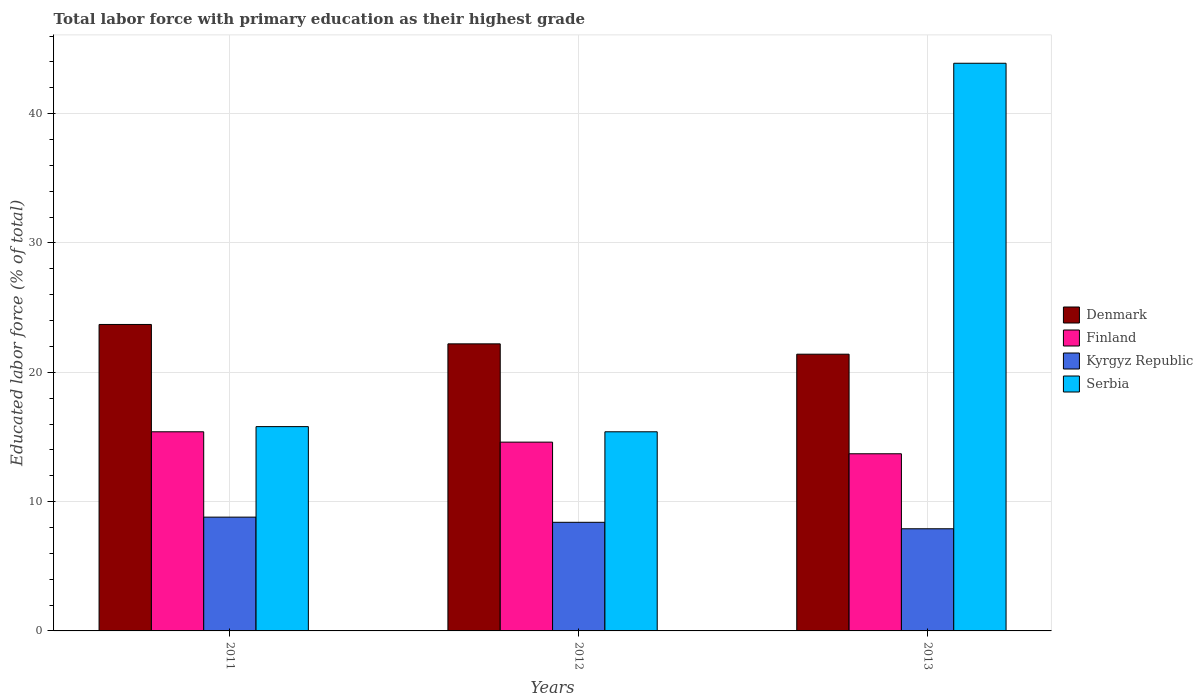How many different coloured bars are there?
Your answer should be very brief. 4. How many groups of bars are there?
Keep it short and to the point. 3. Are the number of bars per tick equal to the number of legend labels?
Ensure brevity in your answer.  Yes. How many bars are there on the 1st tick from the left?
Ensure brevity in your answer.  4. How many bars are there on the 1st tick from the right?
Give a very brief answer. 4. What is the label of the 2nd group of bars from the left?
Ensure brevity in your answer.  2012. In how many cases, is the number of bars for a given year not equal to the number of legend labels?
Provide a succinct answer. 0. What is the percentage of total labor force with primary education in Denmark in 2011?
Ensure brevity in your answer.  23.7. Across all years, what is the maximum percentage of total labor force with primary education in Kyrgyz Republic?
Make the answer very short. 8.8. Across all years, what is the minimum percentage of total labor force with primary education in Serbia?
Your answer should be compact. 15.4. In which year was the percentage of total labor force with primary education in Finland maximum?
Offer a terse response. 2011. What is the total percentage of total labor force with primary education in Denmark in the graph?
Offer a very short reply. 67.3. What is the difference between the percentage of total labor force with primary education in Finland in 2011 and that in 2012?
Your response must be concise. 0.8. What is the difference between the percentage of total labor force with primary education in Kyrgyz Republic in 2011 and the percentage of total labor force with primary education in Serbia in 2013?
Give a very brief answer. -35.1. What is the average percentage of total labor force with primary education in Serbia per year?
Ensure brevity in your answer.  25.03. In the year 2013, what is the difference between the percentage of total labor force with primary education in Denmark and percentage of total labor force with primary education in Finland?
Your response must be concise. 7.7. In how many years, is the percentage of total labor force with primary education in Denmark greater than 2 %?
Offer a very short reply. 3. What is the ratio of the percentage of total labor force with primary education in Finland in 2012 to that in 2013?
Provide a succinct answer. 1.07. Is the percentage of total labor force with primary education in Finland in 2012 less than that in 2013?
Make the answer very short. No. Is the difference between the percentage of total labor force with primary education in Denmark in 2012 and 2013 greater than the difference between the percentage of total labor force with primary education in Finland in 2012 and 2013?
Provide a succinct answer. No. What is the difference between the highest and the second highest percentage of total labor force with primary education in Finland?
Make the answer very short. 0.8. What is the difference between the highest and the lowest percentage of total labor force with primary education in Kyrgyz Republic?
Your response must be concise. 0.9. In how many years, is the percentage of total labor force with primary education in Finland greater than the average percentage of total labor force with primary education in Finland taken over all years?
Your answer should be very brief. 2. Is the sum of the percentage of total labor force with primary education in Kyrgyz Republic in 2011 and 2012 greater than the maximum percentage of total labor force with primary education in Serbia across all years?
Make the answer very short. No. Is it the case that in every year, the sum of the percentage of total labor force with primary education in Finland and percentage of total labor force with primary education in Serbia is greater than the sum of percentage of total labor force with primary education in Denmark and percentage of total labor force with primary education in Kyrgyz Republic?
Your response must be concise. Yes. What does the 3rd bar from the left in 2013 represents?
Offer a terse response. Kyrgyz Republic. What does the 3rd bar from the right in 2011 represents?
Your answer should be compact. Finland. Is it the case that in every year, the sum of the percentage of total labor force with primary education in Denmark and percentage of total labor force with primary education in Serbia is greater than the percentage of total labor force with primary education in Kyrgyz Republic?
Provide a succinct answer. Yes. Are all the bars in the graph horizontal?
Offer a very short reply. No. What is the difference between two consecutive major ticks on the Y-axis?
Give a very brief answer. 10. Are the values on the major ticks of Y-axis written in scientific E-notation?
Ensure brevity in your answer.  No. Does the graph contain any zero values?
Give a very brief answer. No. Where does the legend appear in the graph?
Your answer should be compact. Center right. What is the title of the graph?
Provide a succinct answer. Total labor force with primary education as their highest grade. Does "Paraguay" appear as one of the legend labels in the graph?
Ensure brevity in your answer.  No. What is the label or title of the X-axis?
Keep it short and to the point. Years. What is the label or title of the Y-axis?
Provide a succinct answer. Educated labor force (% of total). What is the Educated labor force (% of total) of Denmark in 2011?
Your answer should be compact. 23.7. What is the Educated labor force (% of total) of Finland in 2011?
Ensure brevity in your answer.  15.4. What is the Educated labor force (% of total) in Kyrgyz Republic in 2011?
Your response must be concise. 8.8. What is the Educated labor force (% of total) of Serbia in 2011?
Offer a very short reply. 15.8. What is the Educated labor force (% of total) in Denmark in 2012?
Your response must be concise. 22.2. What is the Educated labor force (% of total) in Finland in 2012?
Provide a succinct answer. 14.6. What is the Educated labor force (% of total) of Kyrgyz Republic in 2012?
Provide a short and direct response. 8.4. What is the Educated labor force (% of total) of Serbia in 2012?
Offer a very short reply. 15.4. What is the Educated labor force (% of total) of Denmark in 2013?
Make the answer very short. 21.4. What is the Educated labor force (% of total) of Finland in 2013?
Your answer should be compact. 13.7. What is the Educated labor force (% of total) in Kyrgyz Republic in 2013?
Provide a short and direct response. 7.9. What is the Educated labor force (% of total) in Serbia in 2013?
Keep it short and to the point. 43.9. Across all years, what is the maximum Educated labor force (% of total) in Denmark?
Make the answer very short. 23.7. Across all years, what is the maximum Educated labor force (% of total) in Finland?
Ensure brevity in your answer.  15.4. Across all years, what is the maximum Educated labor force (% of total) in Kyrgyz Republic?
Provide a succinct answer. 8.8. Across all years, what is the maximum Educated labor force (% of total) of Serbia?
Your answer should be very brief. 43.9. Across all years, what is the minimum Educated labor force (% of total) of Denmark?
Your response must be concise. 21.4. Across all years, what is the minimum Educated labor force (% of total) in Finland?
Offer a terse response. 13.7. Across all years, what is the minimum Educated labor force (% of total) of Kyrgyz Republic?
Give a very brief answer. 7.9. Across all years, what is the minimum Educated labor force (% of total) in Serbia?
Provide a short and direct response. 15.4. What is the total Educated labor force (% of total) in Denmark in the graph?
Provide a succinct answer. 67.3. What is the total Educated labor force (% of total) in Finland in the graph?
Provide a succinct answer. 43.7. What is the total Educated labor force (% of total) in Kyrgyz Republic in the graph?
Ensure brevity in your answer.  25.1. What is the total Educated labor force (% of total) of Serbia in the graph?
Your response must be concise. 75.1. What is the difference between the Educated labor force (% of total) of Finland in 2011 and that in 2012?
Your answer should be compact. 0.8. What is the difference between the Educated labor force (% of total) of Serbia in 2011 and that in 2012?
Make the answer very short. 0.4. What is the difference between the Educated labor force (% of total) of Kyrgyz Republic in 2011 and that in 2013?
Provide a succinct answer. 0.9. What is the difference between the Educated labor force (% of total) of Serbia in 2011 and that in 2013?
Your response must be concise. -28.1. What is the difference between the Educated labor force (% of total) of Finland in 2012 and that in 2013?
Provide a succinct answer. 0.9. What is the difference between the Educated labor force (% of total) of Kyrgyz Republic in 2012 and that in 2013?
Offer a terse response. 0.5. What is the difference between the Educated labor force (% of total) of Serbia in 2012 and that in 2013?
Give a very brief answer. -28.5. What is the difference between the Educated labor force (% of total) of Finland in 2011 and the Educated labor force (% of total) of Serbia in 2012?
Keep it short and to the point. 0. What is the difference between the Educated labor force (% of total) of Kyrgyz Republic in 2011 and the Educated labor force (% of total) of Serbia in 2012?
Your answer should be very brief. -6.6. What is the difference between the Educated labor force (% of total) in Denmark in 2011 and the Educated labor force (% of total) in Finland in 2013?
Make the answer very short. 10. What is the difference between the Educated labor force (% of total) of Denmark in 2011 and the Educated labor force (% of total) of Serbia in 2013?
Your answer should be very brief. -20.2. What is the difference between the Educated labor force (% of total) of Finland in 2011 and the Educated labor force (% of total) of Kyrgyz Republic in 2013?
Your response must be concise. 7.5. What is the difference between the Educated labor force (% of total) of Finland in 2011 and the Educated labor force (% of total) of Serbia in 2013?
Offer a terse response. -28.5. What is the difference between the Educated labor force (% of total) of Kyrgyz Republic in 2011 and the Educated labor force (% of total) of Serbia in 2013?
Make the answer very short. -35.1. What is the difference between the Educated labor force (% of total) of Denmark in 2012 and the Educated labor force (% of total) of Finland in 2013?
Offer a very short reply. 8.5. What is the difference between the Educated labor force (% of total) in Denmark in 2012 and the Educated labor force (% of total) in Serbia in 2013?
Make the answer very short. -21.7. What is the difference between the Educated labor force (% of total) in Finland in 2012 and the Educated labor force (% of total) in Kyrgyz Republic in 2013?
Offer a terse response. 6.7. What is the difference between the Educated labor force (% of total) of Finland in 2012 and the Educated labor force (% of total) of Serbia in 2013?
Your answer should be very brief. -29.3. What is the difference between the Educated labor force (% of total) of Kyrgyz Republic in 2012 and the Educated labor force (% of total) of Serbia in 2013?
Offer a very short reply. -35.5. What is the average Educated labor force (% of total) in Denmark per year?
Provide a short and direct response. 22.43. What is the average Educated labor force (% of total) in Finland per year?
Keep it short and to the point. 14.57. What is the average Educated labor force (% of total) in Kyrgyz Republic per year?
Offer a very short reply. 8.37. What is the average Educated labor force (% of total) in Serbia per year?
Your response must be concise. 25.03. In the year 2011, what is the difference between the Educated labor force (% of total) of Denmark and Educated labor force (% of total) of Finland?
Your response must be concise. 8.3. In the year 2011, what is the difference between the Educated labor force (% of total) of Denmark and Educated labor force (% of total) of Kyrgyz Republic?
Offer a terse response. 14.9. In the year 2011, what is the difference between the Educated labor force (% of total) in Finland and Educated labor force (% of total) in Kyrgyz Republic?
Offer a very short reply. 6.6. In the year 2011, what is the difference between the Educated labor force (% of total) of Finland and Educated labor force (% of total) of Serbia?
Your answer should be very brief. -0.4. In the year 2012, what is the difference between the Educated labor force (% of total) of Denmark and Educated labor force (% of total) of Finland?
Provide a succinct answer. 7.6. In the year 2012, what is the difference between the Educated labor force (% of total) in Denmark and Educated labor force (% of total) in Kyrgyz Republic?
Your answer should be compact. 13.8. In the year 2012, what is the difference between the Educated labor force (% of total) of Denmark and Educated labor force (% of total) of Serbia?
Your answer should be very brief. 6.8. In the year 2012, what is the difference between the Educated labor force (% of total) of Finland and Educated labor force (% of total) of Kyrgyz Republic?
Your answer should be compact. 6.2. In the year 2012, what is the difference between the Educated labor force (% of total) in Finland and Educated labor force (% of total) in Serbia?
Provide a succinct answer. -0.8. In the year 2012, what is the difference between the Educated labor force (% of total) of Kyrgyz Republic and Educated labor force (% of total) of Serbia?
Offer a very short reply. -7. In the year 2013, what is the difference between the Educated labor force (% of total) in Denmark and Educated labor force (% of total) in Kyrgyz Republic?
Your answer should be compact. 13.5. In the year 2013, what is the difference between the Educated labor force (% of total) of Denmark and Educated labor force (% of total) of Serbia?
Provide a short and direct response. -22.5. In the year 2013, what is the difference between the Educated labor force (% of total) in Finland and Educated labor force (% of total) in Kyrgyz Republic?
Ensure brevity in your answer.  5.8. In the year 2013, what is the difference between the Educated labor force (% of total) in Finland and Educated labor force (% of total) in Serbia?
Provide a succinct answer. -30.2. In the year 2013, what is the difference between the Educated labor force (% of total) of Kyrgyz Republic and Educated labor force (% of total) of Serbia?
Your response must be concise. -36. What is the ratio of the Educated labor force (% of total) in Denmark in 2011 to that in 2012?
Ensure brevity in your answer.  1.07. What is the ratio of the Educated labor force (% of total) in Finland in 2011 to that in 2012?
Provide a short and direct response. 1.05. What is the ratio of the Educated labor force (% of total) in Kyrgyz Republic in 2011 to that in 2012?
Offer a very short reply. 1.05. What is the ratio of the Educated labor force (% of total) of Serbia in 2011 to that in 2012?
Provide a succinct answer. 1.03. What is the ratio of the Educated labor force (% of total) of Denmark in 2011 to that in 2013?
Your answer should be very brief. 1.11. What is the ratio of the Educated labor force (% of total) of Finland in 2011 to that in 2013?
Provide a short and direct response. 1.12. What is the ratio of the Educated labor force (% of total) of Kyrgyz Republic in 2011 to that in 2013?
Offer a very short reply. 1.11. What is the ratio of the Educated labor force (% of total) of Serbia in 2011 to that in 2013?
Keep it short and to the point. 0.36. What is the ratio of the Educated labor force (% of total) of Denmark in 2012 to that in 2013?
Your answer should be compact. 1.04. What is the ratio of the Educated labor force (% of total) of Finland in 2012 to that in 2013?
Keep it short and to the point. 1.07. What is the ratio of the Educated labor force (% of total) of Kyrgyz Republic in 2012 to that in 2013?
Your answer should be very brief. 1.06. What is the ratio of the Educated labor force (% of total) of Serbia in 2012 to that in 2013?
Make the answer very short. 0.35. What is the difference between the highest and the second highest Educated labor force (% of total) of Denmark?
Provide a short and direct response. 1.5. What is the difference between the highest and the second highest Educated labor force (% of total) in Kyrgyz Republic?
Your answer should be very brief. 0.4. What is the difference between the highest and the second highest Educated labor force (% of total) in Serbia?
Make the answer very short. 28.1. What is the difference between the highest and the lowest Educated labor force (% of total) of Kyrgyz Republic?
Your response must be concise. 0.9. What is the difference between the highest and the lowest Educated labor force (% of total) of Serbia?
Keep it short and to the point. 28.5. 